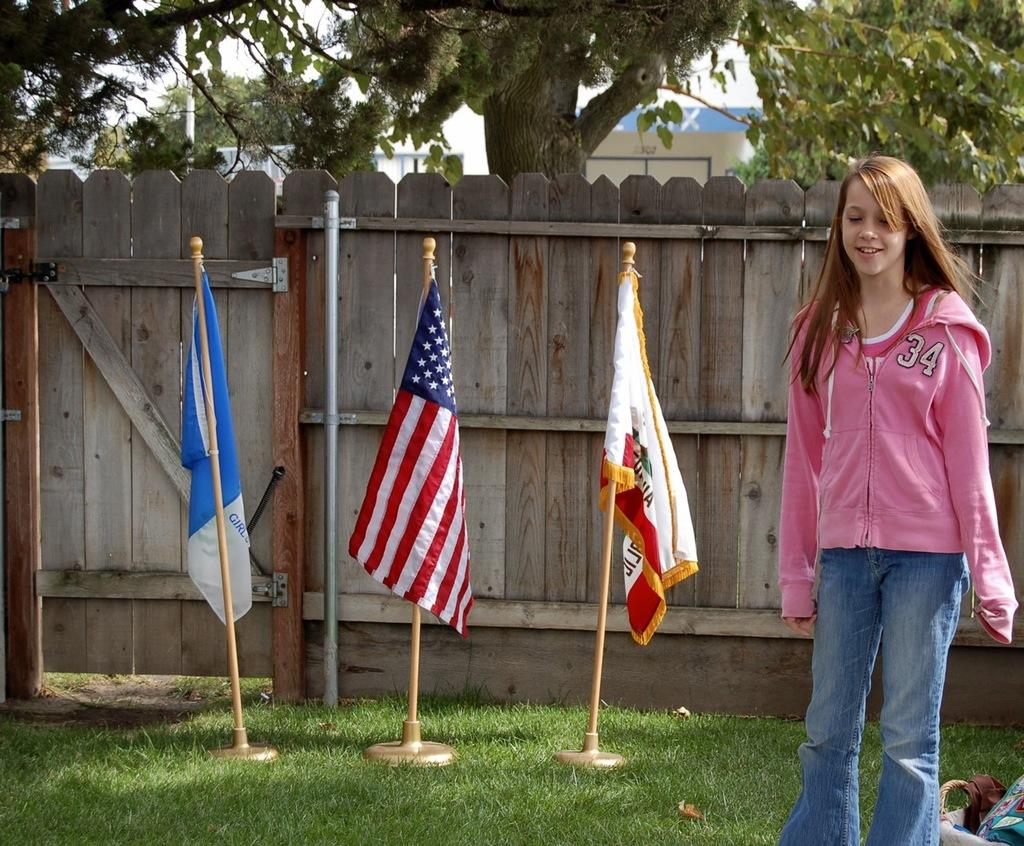What is the person in the image doing? There is a person standing on the ground in the image. What is located near the person? There is a basket with objects near the person. What can be seen in the image besides the person and the basket? There are flags, a wooden fence with a gate, and trees in the image. What unit of measurement is used to determine the length of the sail in the image? There is no sail present in the image, so it is not possible to determine the unit of measurement used for its length. 